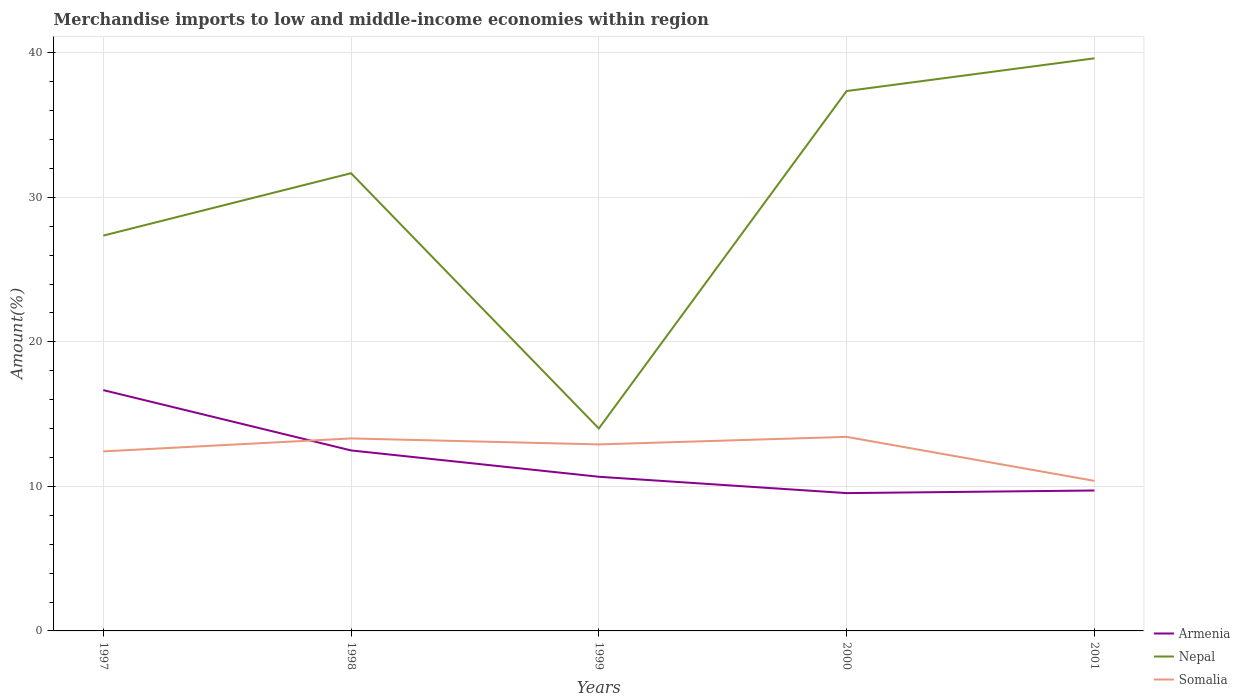Does the line corresponding to Nepal intersect with the line corresponding to Armenia?
Ensure brevity in your answer.  No. Across all years, what is the maximum percentage of amount earned from merchandise imports in Nepal?
Offer a terse response. 14.01. What is the total percentage of amount earned from merchandise imports in Somalia in the graph?
Your response must be concise. 2.04. What is the difference between the highest and the second highest percentage of amount earned from merchandise imports in Somalia?
Ensure brevity in your answer.  3.05. What is the difference between the highest and the lowest percentage of amount earned from merchandise imports in Somalia?
Your answer should be very brief. 3. Is the percentage of amount earned from merchandise imports in Somalia strictly greater than the percentage of amount earned from merchandise imports in Nepal over the years?
Your response must be concise. Yes. How many years are there in the graph?
Provide a succinct answer. 5. Are the values on the major ticks of Y-axis written in scientific E-notation?
Provide a succinct answer. No. Does the graph contain any zero values?
Make the answer very short. No. Where does the legend appear in the graph?
Your response must be concise. Bottom right. How are the legend labels stacked?
Your response must be concise. Vertical. What is the title of the graph?
Your answer should be very brief. Merchandise imports to low and middle-income economies within region. What is the label or title of the Y-axis?
Offer a terse response. Amount(%). What is the Amount(%) of Armenia in 1997?
Offer a terse response. 16.66. What is the Amount(%) of Nepal in 1997?
Provide a short and direct response. 27.35. What is the Amount(%) of Somalia in 1997?
Make the answer very short. 12.42. What is the Amount(%) in Armenia in 1998?
Your response must be concise. 12.49. What is the Amount(%) in Nepal in 1998?
Provide a succinct answer. 31.67. What is the Amount(%) in Somalia in 1998?
Offer a terse response. 13.32. What is the Amount(%) of Armenia in 1999?
Provide a succinct answer. 10.67. What is the Amount(%) in Nepal in 1999?
Keep it short and to the point. 14.01. What is the Amount(%) in Somalia in 1999?
Give a very brief answer. 12.91. What is the Amount(%) in Armenia in 2000?
Keep it short and to the point. 9.54. What is the Amount(%) in Nepal in 2000?
Your answer should be compact. 37.36. What is the Amount(%) of Somalia in 2000?
Your answer should be compact. 13.43. What is the Amount(%) of Armenia in 2001?
Your answer should be very brief. 9.72. What is the Amount(%) of Nepal in 2001?
Give a very brief answer. 39.62. What is the Amount(%) in Somalia in 2001?
Give a very brief answer. 10.38. Across all years, what is the maximum Amount(%) in Armenia?
Your answer should be very brief. 16.66. Across all years, what is the maximum Amount(%) of Nepal?
Your response must be concise. 39.62. Across all years, what is the maximum Amount(%) in Somalia?
Give a very brief answer. 13.43. Across all years, what is the minimum Amount(%) of Armenia?
Your answer should be very brief. 9.54. Across all years, what is the minimum Amount(%) of Nepal?
Ensure brevity in your answer.  14.01. Across all years, what is the minimum Amount(%) in Somalia?
Your answer should be very brief. 10.38. What is the total Amount(%) of Armenia in the graph?
Offer a very short reply. 59.07. What is the total Amount(%) of Nepal in the graph?
Your response must be concise. 150.01. What is the total Amount(%) in Somalia in the graph?
Provide a short and direct response. 62.46. What is the difference between the Amount(%) in Armenia in 1997 and that in 1998?
Ensure brevity in your answer.  4.17. What is the difference between the Amount(%) of Nepal in 1997 and that in 1998?
Make the answer very short. -4.32. What is the difference between the Amount(%) of Somalia in 1997 and that in 1998?
Make the answer very short. -0.9. What is the difference between the Amount(%) in Armenia in 1997 and that in 1999?
Offer a terse response. 6. What is the difference between the Amount(%) in Nepal in 1997 and that in 1999?
Your response must be concise. 13.34. What is the difference between the Amount(%) of Somalia in 1997 and that in 1999?
Your answer should be compact. -0.48. What is the difference between the Amount(%) in Armenia in 1997 and that in 2000?
Provide a short and direct response. 7.13. What is the difference between the Amount(%) in Nepal in 1997 and that in 2000?
Ensure brevity in your answer.  -10. What is the difference between the Amount(%) of Somalia in 1997 and that in 2000?
Your answer should be compact. -1.01. What is the difference between the Amount(%) in Armenia in 1997 and that in 2001?
Keep it short and to the point. 6.95. What is the difference between the Amount(%) of Nepal in 1997 and that in 2001?
Offer a very short reply. -12.27. What is the difference between the Amount(%) of Somalia in 1997 and that in 2001?
Your answer should be very brief. 2.04. What is the difference between the Amount(%) of Armenia in 1998 and that in 1999?
Your response must be concise. 1.82. What is the difference between the Amount(%) in Nepal in 1998 and that in 1999?
Make the answer very short. 17.66. What is the difference between the Amount(%) of Somalia in 1998 and that in 1999?
Your answer should be compact. 0.41. What is the difference between the Amount(%) in Armenia in 1998 and that in 2000?
Keep it short and to the point. 2.95. What is the difference between the Amount(%) in Nepal in 1998 and that in 2000?
Your answer should be very brief. -5.69. What is the difference between the Amount(%) of Somalia in 1998 and that in 2000?
Provide a succinct answer. -0.11. What is the difference between the Amount(%) in Armenia in 1998 and that in 2001?
Your answer should be very brief. 2.77. What is the difference between the Amount(%) in Nepal in 1998 and that in 2001?
Your answer should be compact. -7.95. What is the difference between the Amount(%) in Somalia in 1998 and that in 2001?
Ensure brevity in your answer.  2.94. What is the difference between the Amount(%) of Armenia in 1999 and that in 2000?
Provide a short and direct response. 1.13. What is the difference between the Amount(%) in Nepal in 1999 and that in 2000?
Give a very brief answer. -23.35. What is the difference between the Amount(%) of Somalia in 1999 and that in 2000?
Ensure brevity in your answer.  -0.52. What is the difference between the Amount(%) in Armenia in 1999 and that in 2001?
Your answer should be very brief. 0.95. What is the difference between the Amount(%) in Nepal in 1999 and that in 2001?
Your answer should be compact. -25.61. What is the difference between the Amount(%) in Somalia in 1999 and that in 2001?
Keep it short and to the point. 2.52. What is the difference between the Amount(%) in Armenia in 2000 and that in 2001?
Offer a terse response. -0.18. What is the difference between the Amount(%) of Nepal in 2000 and that in 2001?
Your response must be concise. -2.27. What is the difference between the Amount(%) in Somalia in 2000 and that in 2001?
Your answer should be compact. 3.05. What is the difference between the Amount(%) of Armenia in 1997 and the Amount(%) of Nepal in 1998?
Your response must be concise. -15.01. What is the difference between the Amount(%) of Armenia in 1997 and the Amount(%) of Somalia in 1998?
Offer a terse response. 3.34. What is the difference between the Amount(%) in Nepal in 1997 and the Amount(%) in Somalia in 1998?
Your answer should be very brief. 14.03. What is the difference between the Amount(%) of Armenia in 1997 and the Amount(%) of Nepal in 1999?
Offer a terse response. 2.65. What is the difference between the Amount(%) of Armenia in 1997 and the Amount(%) of Somalia in 1999?
Your answer should be very brief. 3.76. What is the difference between the Amount(%) in Nepal in 1997 and the Amount(%) in Somalia in 1999?
Ensure brevity in your answer.  14.45. What is the difference between the Amount(%) in Armenia in 1997 and the Amount(%) in Nepal in 2000?
Your answer should be very brief. -20.69. What is the difference between the Amount(%) in Armenia in 1997 and the Amount(%) in Somalia in 2000?
Provide a succinct answer. 3.23. What is the difference between the Amount(%) of Nepal in 1997 and the Amount(%) of Somalia in 2000?
Offer a very short reply. 13.92. What is the difference between the Amount(%) in Armenia in 1997 and the Amount(%) in Nepal in 2001?
Your response must be concise. -22.96. What is the difference between the Amount(%) in Armenia in 1997 and the Amount(%) in Somalia in 2001?
Give a very brief answer. 6.28. What is the difference between the Amount(%) of Nepal in 1997 and the Amount(%) of Somalia in 2001?
Give a very brief answer. 16.97. What is the difference between the Amount(%) of Armenia in 1998 and the Amount(%) of Nepal in 1999?
Provide a short and direct response. -1.52. What is the difference between the Amount(%) of Armenia in 1998 and the Amount(%) of Somalia in 1999?
Your answer should be compact. -0.42. What is the difference between the Amount(%) in Nepal in 1998 and the Amount(%) in Somalia in 1999?
Offer a very short reply. 18.76. What is the difference between the Amount(%) of Armenia in 1998 and the Amount(%) of Nepal in 2000?
Make the answer very short. -24.87. What is the difference between the Amount(%) of Armenia in 1998 and the Amount(%) of Somalia in 2000?
Provide a succinct answer. -0.94. What is the difference between the Amount(%) of Nepal in 1998 and the Amount(%) of Somalia in 2000?
Provide a short and direct response. 18.24. What is the difference between the Amount(%) of Armenia in 1998 and the Amount(%) of Nepal in 2001?
Offer a terse response. -27.13. What is the difference between the Amount(%) of Armenia in 1998 and the Amount(%) of Somalia in 2001?
Keep it short and to the point. 2.11. What is the difference between the Amount(%) in Nepal in 1998 and the Amount(%) in Somalia in 2001?
Offer a very short reply. 21.29. What is the difference between the Amount(%) in Armenia in 1999 and the Amount(%) in Nepal in 2000?
Make the answer very short. -26.69. What is the difference between the Amount(%) in Armenia in 1999 and the Amount(%) in Somalia in 2000?
Give a very brief answer. -2.76. What is the difference between the Amount(%) of Nepal in 1999 and the Amount(%) of Somalia in 2000?
Your response must be concise. 0.58. What is the difference between the Amount(%) of Armenia in 1999 and the Amount(%) of Nepal in 2001?
Give a very brief answer. -28.95. What is the difference between the Amount(%) of Armenia in 1999 and the Amount(%) of Somalia in 2001?
Offer a terse response. 0.28. What is the difference between the Amount(%) of Nepal in 1999 and the Amount(%) of Somalia in 2001?
Give a very brief answer. 3.63. What is the difference between the Amount(%) in Armenia in 2000 and the Amount(%) in Nepal in 2001?
Your answer should be compact. -30.09. What is the difference between the Amount(%) of Armenia in 2000 and the Amount(%) of Somalia in 2001?
Provide a short and direct response. -0.85. What is the difference between the Amount(%) in Nepal in 2000 and the Amount(%) in Somalia in 2001?
Your answer should be compact. 26.97. What is the average Amount(%) in Armenia per year?
Your answer should be very brief. 11.81. What is the average Amount(%) of Nepal per year?
Ensure brevity in your answer.  30. What is the average Amount(%) in Somalia per year?
Provide a short and direct response. 12.49. In the year 1997, what is the difference between the Amount(%) in Armenia and Amount(%) in Nepal?
Offer a terse response. -10.69. In the year 1997, what is the difference between the Amount(%) in Armenia and Amount(%) in Somalia?
Your answer should be very brief. 4.24. In the year 1997, what is the difference between the Amount(%) of Nepal and Amount(%) of Somalia?
Your response must be concise. 14.93. In the year 1998, what is the difference between the Amount(%) in Armenia and Amount(%) in Nepal?
Keep it short and to the point. -19.18. In the year 1998, what is the difference between the Amount(%) of Armenia and Amount(%) of Somalia?
Provide a short and direct response. -0.83. In the year 1998, what is the difference between the Amount(%) in Nepal and Amount(%) in Somalia?
Make the answer very short. 18.35. In the year 1999, what is the difference between the Amount(%) of Armenia and Amount(%) of Nepal?
Offer a terse response. -3.34. In the year 1999, what is the difference between the Amount(%) in Armenia and Amount(%) in Somalia?
Provide a succinct answer. -2.24. In the year 1999, what is the difference between the Amount(%) in Nepal and Amount(%) in Somalia?
Ensure brevity in your answer.  1.1. In the year 2000, what is the difference between the Amount(%) in Armenia and Amount(%) in Nepal?
Your answer should be compact. -27.82. In the year 2000, what is the difference between the Amount(%) of Armenia and Amount(%) of Somalia?
Offer a very short reply. -3.89. In the year 2000, what is the difference between the Amount(%) of Nepal and Amount(%) of Somalia?
Offer a terse response. 23.93. In the year 2001, what is the difference between the Amount(%) in Armenia and Amount(%) in Nepal?
Provide a succinct answer. -29.9. In the year 2001, what is the difference between the Amount(%) in Armenia and Amount(%) in Somalia?
Offer a very short reply. -0.67. In the year 2001, what is the difference between the Amount(%) in Nepal and Amount(%) in Somalia?
Keep it short and to the point. 29.24. What is the ratio of the Amount(%) of Armenia in 1997 to that in 1998?
Ensure brevity in your answer.  1.33. What is the ratio of the Amount(%) in Nepal in 1997 to that in 1998?
Keep it short and to the point. 0.86. What is the ratio of the Amount(%) of Somalia in 1997 to that in 1998?
Make the answer very short. 0.93. What is the ratio of the Amount(%) of Armenia in 1997 to that in 1999?
Provide a short and direct response. 1.56. What is the ratio of the Amount(%) in Nepal in 1997 to that in 1999?
Offer a very short reply. 1.95. What is the ratio of the Amount(%) of Somalia in 1997 to that in 1999?
Give a very brief answer. 0.96. What is the ratio of the Amount(%) in Armenia in 1997 to that in 2000?
Keep it short and to the point. 1.75. What is the ratio of the Amount(%) in Nepal in 1997 to that in 2000?
Make the answer very short. 0.73. What is the ratio of the Amount(%) in Somalia in 1997 to that in 2000?
Make the answer very short. 0.93. What is the ratio of the Amount(%) of Armenia in 1997 to that in 2001?
Provide a short and direct response. 1.71. What is the ratio of the Amount(%) of Nepal in 1997 to that in 2001?
Provide a succinct answer. 0.69. What is the ratio of the Amount(%) of Somalia in 1997 to that in 2001?
Your response must be concise. 1.2. What is the ratio of the Amount(%) of Armenia in 1998 to that in 1999?
Offer a very short reply. 1.17. What is the ratio of the Amount(%) of Nepal in 1998 to that in 1999?
Your answer should be compact. 2.26. What is the ratio of the Amount(%) of Somalia in 1998 to that in 1999?
Provide a succinct answer. 1.03. What is the ratio of the Amount(%) of Armenia in 1998 to that in 2000?
Offer a terse response. 1.31. What is the ratio of the Amount(%) of Nepal in 1998 to that in 2000?
Offer a very short reply. 0.85. What is the ratio of the Amount(%) of Armenia in 1998 to that in 2001?
Give a very brief answer. 1.29. What is the ratio of the Amount(%) of Nepal in 1998 to that in 2001?
Provide a short and direct response. 0.8. What is the ratio of the Amount(%) in Somalia in 1998 to that in 2001?
Give a very brief answer. 1.28. What is the ratio of the Amount(%) of Armenia in 1999 to that in 2000?
Your answer should be very brief. 1.12. What is the ratio of the Amount(%) in Somalia in 1999 to that in 2000?
Provide a succinct answer. 0.96. What is the ratio of the Amount(%) of Armenia in 1999 to that in 2001?
Provide a short and direct response. 1.1. What is the ratio of the Amount(%) of Nepal in 1999 to that in 2001?
Ensure brevity in your answer.  0.35. What is the ratio of the Amount(%) of Somalia in 1999 to that in 2001?
Give a very brief answer. 1.24. What is the ratio of the Amount(%) of Armenia in 2000 to that in 2001?
Your answer should be compact. 0.98. What is the ratio of the Amount(%) in Nepal in 2000 to that in 2001?
Offer a terse response. 0.94. What is the ratio of the Amount(%) of Somalia in 2000 to that in 2001?
Your answer should be compact. 1.29. What is the difference between the highest and the second highest Amount(%) in Armenia?
Ensure brevity in your answer.  4.17. What is the difference between the highest and the second highest Amount(%) of Nepal?
Give a very brief answer. 2.27. What is the difference between the highest and the second highest Amount(%) of Somalia?
Your answer should be compact. 0.11. What is the difference between the highest and the lowest Amount(%) in Armenia?
Make the answer very short. 7.13. What is the difference between the highest and the lowest Amount(%) of Nepal?
Your answer should be very brief. 25.61. What is the difference between the highest and the lowest Amount(%) of Somalia?
Keep it short and to the point. 3.05. 